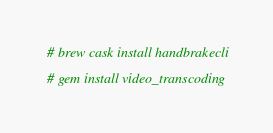<code> <loc_0><loc_0><loc_500><loc_500><_Bash_># brew cask install handbrakecli

# gem install video_transcoding
</code> 